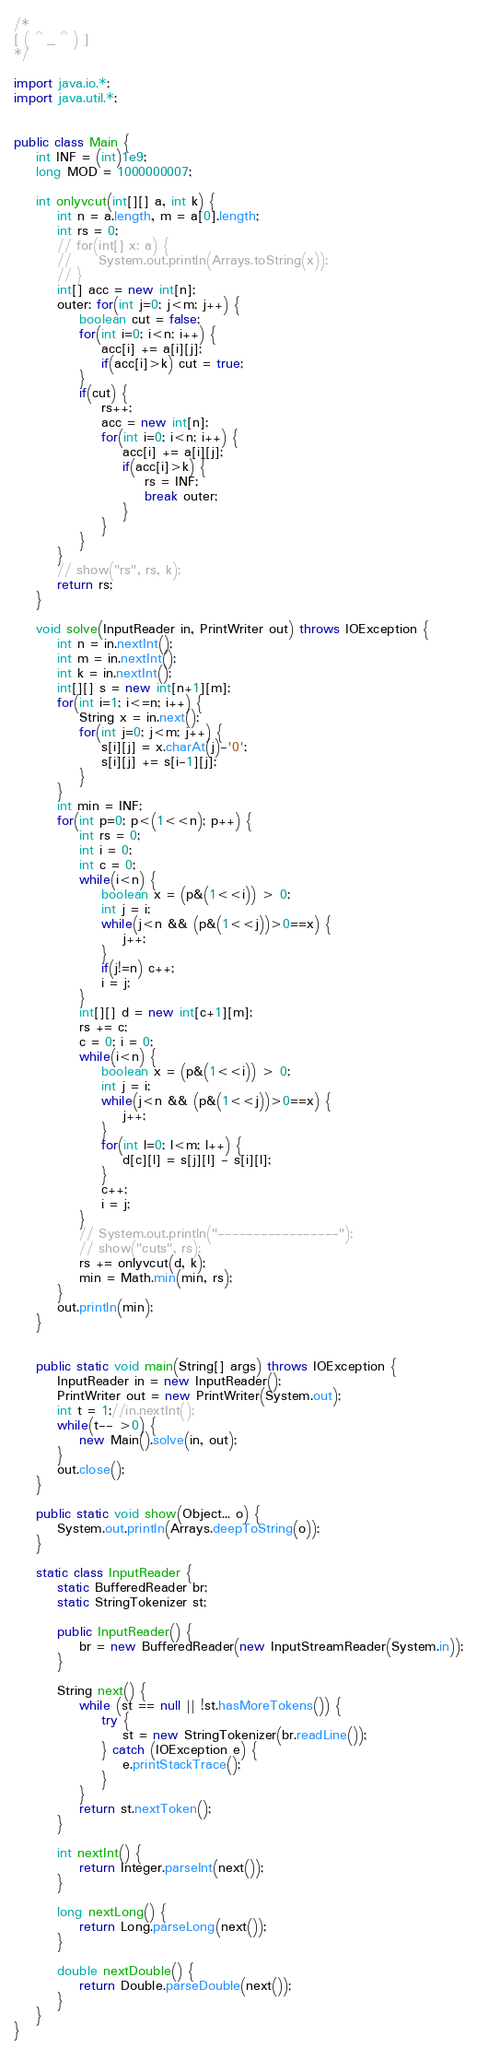Convert code to text. <code><loc_0><loc_0><loc_500><loc_500><_Java_>/*
[ ( ^ _ ^ ) ]
*/

import java.io.*;
import java.util.*;


public class Main {
    int INF = (int)1e9;
    long MOD = 1000000007;

    int onlyvcut(int[][] a, int k) {
        int n = a.length, m = a[0].length;
        int rs = 0;
        // for(int[] x: a) {
        //     System.out.println(Arrays.toString(x));
        // }
        int[] acc = new int[n];
        outer: for(int j=0; j<m; j++) {
            boolean cut = false;
            for(int i=0; i<n; i++) {
                acc[i] += a[i][j];
                if(acc[i]>k) cut = true;
            }
            if(cut) {
                rs++;
                acc = new int[n];
                for(int i=0; i<n; i++) {
                    acc[i] += a[i][j];
                    if(acc[i]>k) {
                        rs = INF;
                        break outer;
                    }
                }
            }
        }
        // show("rs", rs, k);
        return rs;
    }

    void solve(InputReader in, PrintWriter out) throws IOException {
        int n = in.nextInt();
        int m = in.nextInt();
        int k = in.nextInt();
        int[][] s = new int[n+1][m];
        for(int i=1; i<=n; i++) {
            String x = in.next();
            for(int j=0; j<m; j++) {
                s[i][j] = x.charAt(j)-'0';
                s[i][j] += s[i-1][j];
            }
        }
        int min = INF;
        for(int p=0; p<(1<<n); p++) {
            int rs = 0;
            int i = 0;
            int c = 0;
            while(i<n) {
                boolean x = (p&(1<<i)) > 0;
                int j = i;
                while(j<n && (p&(1<<j))>0==x) {
                    j++;
                }
                if(j!=n) c++;
                i = j;
            }
            int[][] d = new int[c+1][m];
            rs += c;
            c = 0; i = 0;
            while(i<n) {
                boolean x = (p&(1<<i)) > 0;
                int j = i;
                while(j<n && (p&(1<<j))>0==x) {
                    j++;
                }
                for(int l=0; l<m; l++) {
                    d[c][l] = s[j][l] - s[i][l];
                }
                c++;
                i = j;
            }
            // System.out.println("-----------------");
            // show("cuts", rs);
            rs += onlyvcut(d, k);
            min = Math.min(min, rs);
        }
        out.println(min);
    }
    

    public static void main(String[] args) throws IOException {
        InputReader in = new InputReader();
        PrintWriter out = new PrintWriter(System.out);
        int t = 1;//in.nextInt();
        while(t-- >0) {
            new Main().solve(in, out);
        }
        out.close();
    }
    
    public static void show(Object... o) {
        System.out.println(Arrays.deepToString(o));
    }
    
    static class InputReader {
        static BufferedReader br;
        static StringTokenizer st;
    
        public InputReader() {
            br = new BufferedReader(new InputStreamReader(System.in));
        }
        
        String next() {
            while (st == null || !st.hasMoreTokens()) {
                try {
                    st = new StringTokenizer(br.readLine());
                } catch (IOException e) {
                    e.printStackTrace();
                }
            }
            return st.nextToken();
        }
        
        int nextInt() {
            return Integer.parseInt(next());
        }
        
        long nextLong() {
            return Long.parseLong(next());
        }
        
        double nextDouble() {
            return Double.parseDouble(next());
        }
    }
}</code> 